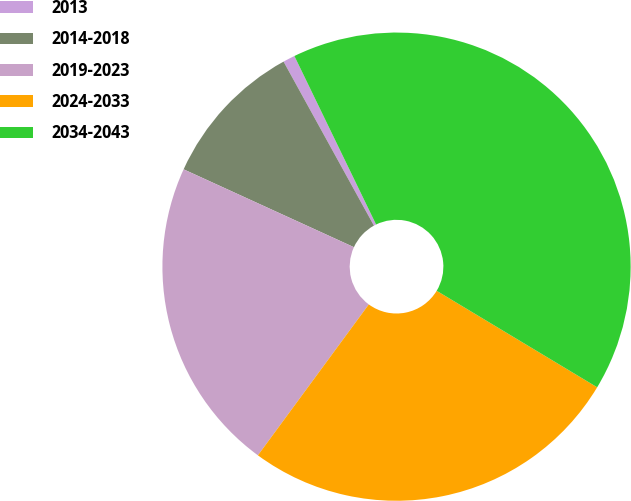Convert chart. <chart><loc_0><loc_0><loc_500><loc_500><pie_chart><fcel>2013<fcel>2014-2018<fcel>2019-2023<fcel>2024-2033<fcel>2034-2043<nl><fcel>0.83%<fcel>10.16%<fcel>21.74%<fcel>26.47%<fcel>40.8%<nl></chart> 